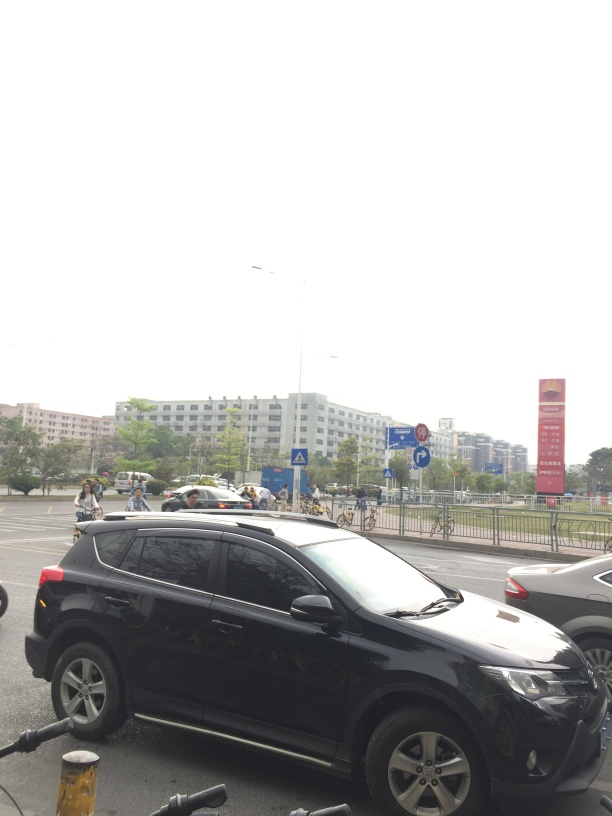Are there any people in the image, and what are they doing? Yes, there are several people visible in the background of the image. They appear to be engaged in typical urban activities: walking, possibly waiting to cross the street, and biking. The presence of people and their active engagement with their environment contributes to the dynamic urban feel of the scene. 